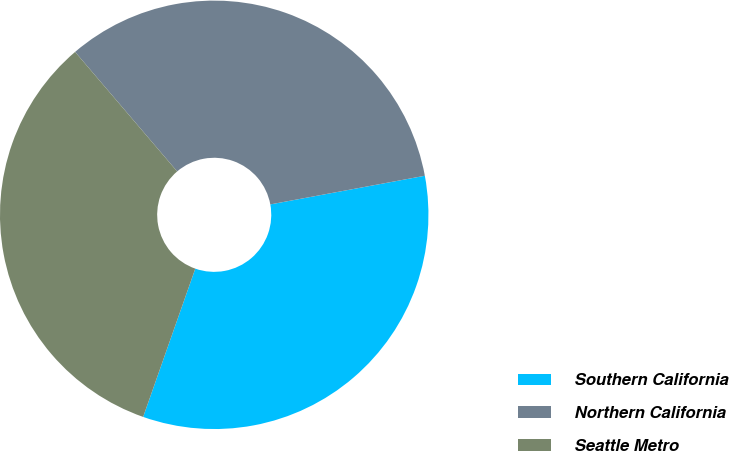Convert chart. <chart><loc_0><loc_0><loc_500><loc_500><pie_chart><fcel>Southern California<fcel>Northern California<fcel>Seattle Metro<nl><fcel>33.3%<fcel>33.33%<fcel>33.37%<nl></chart> 